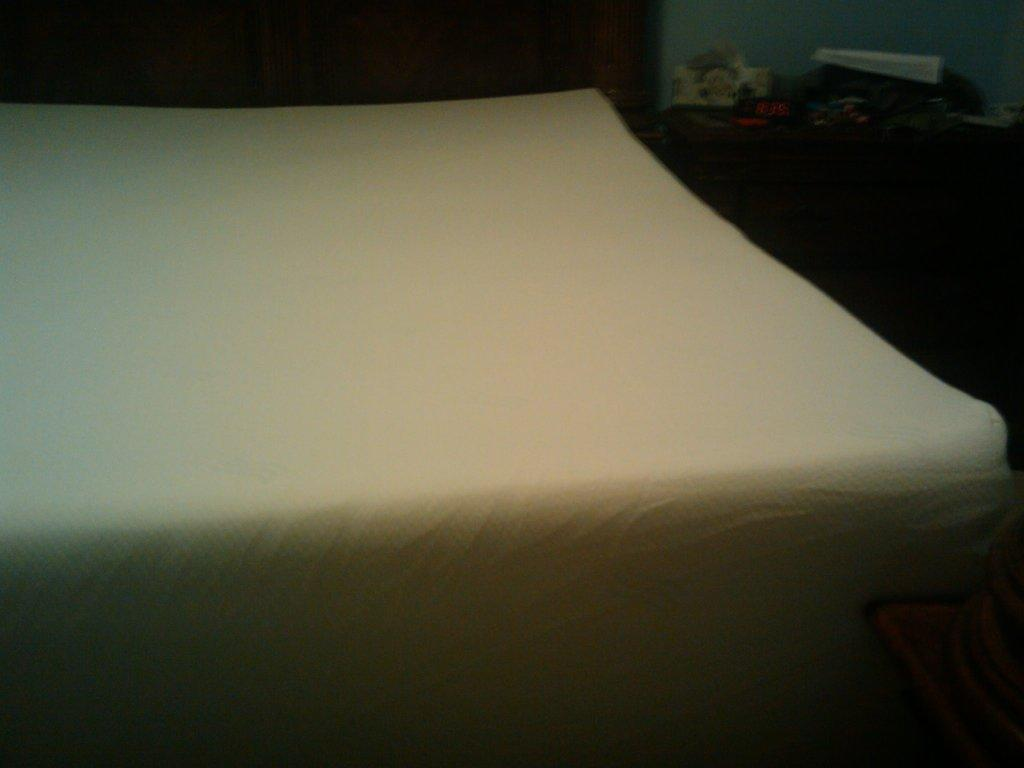What is the main piece of furniture in the center of the image? There is a bed in the center of the image. What type of storage furniture is located on the right side of the image? There are cupboards on the right side of the image. What can be found on top of the cupboards? There are objects on the cupboards. How many firemen are sitting on the chair in the image? There is no chair or firemen present in the image. What is the amount of objects on the cupboards in the image? The number of objects on the cupboards cannot be determined from the image alone, as it only shows their presence and not their quantity. 